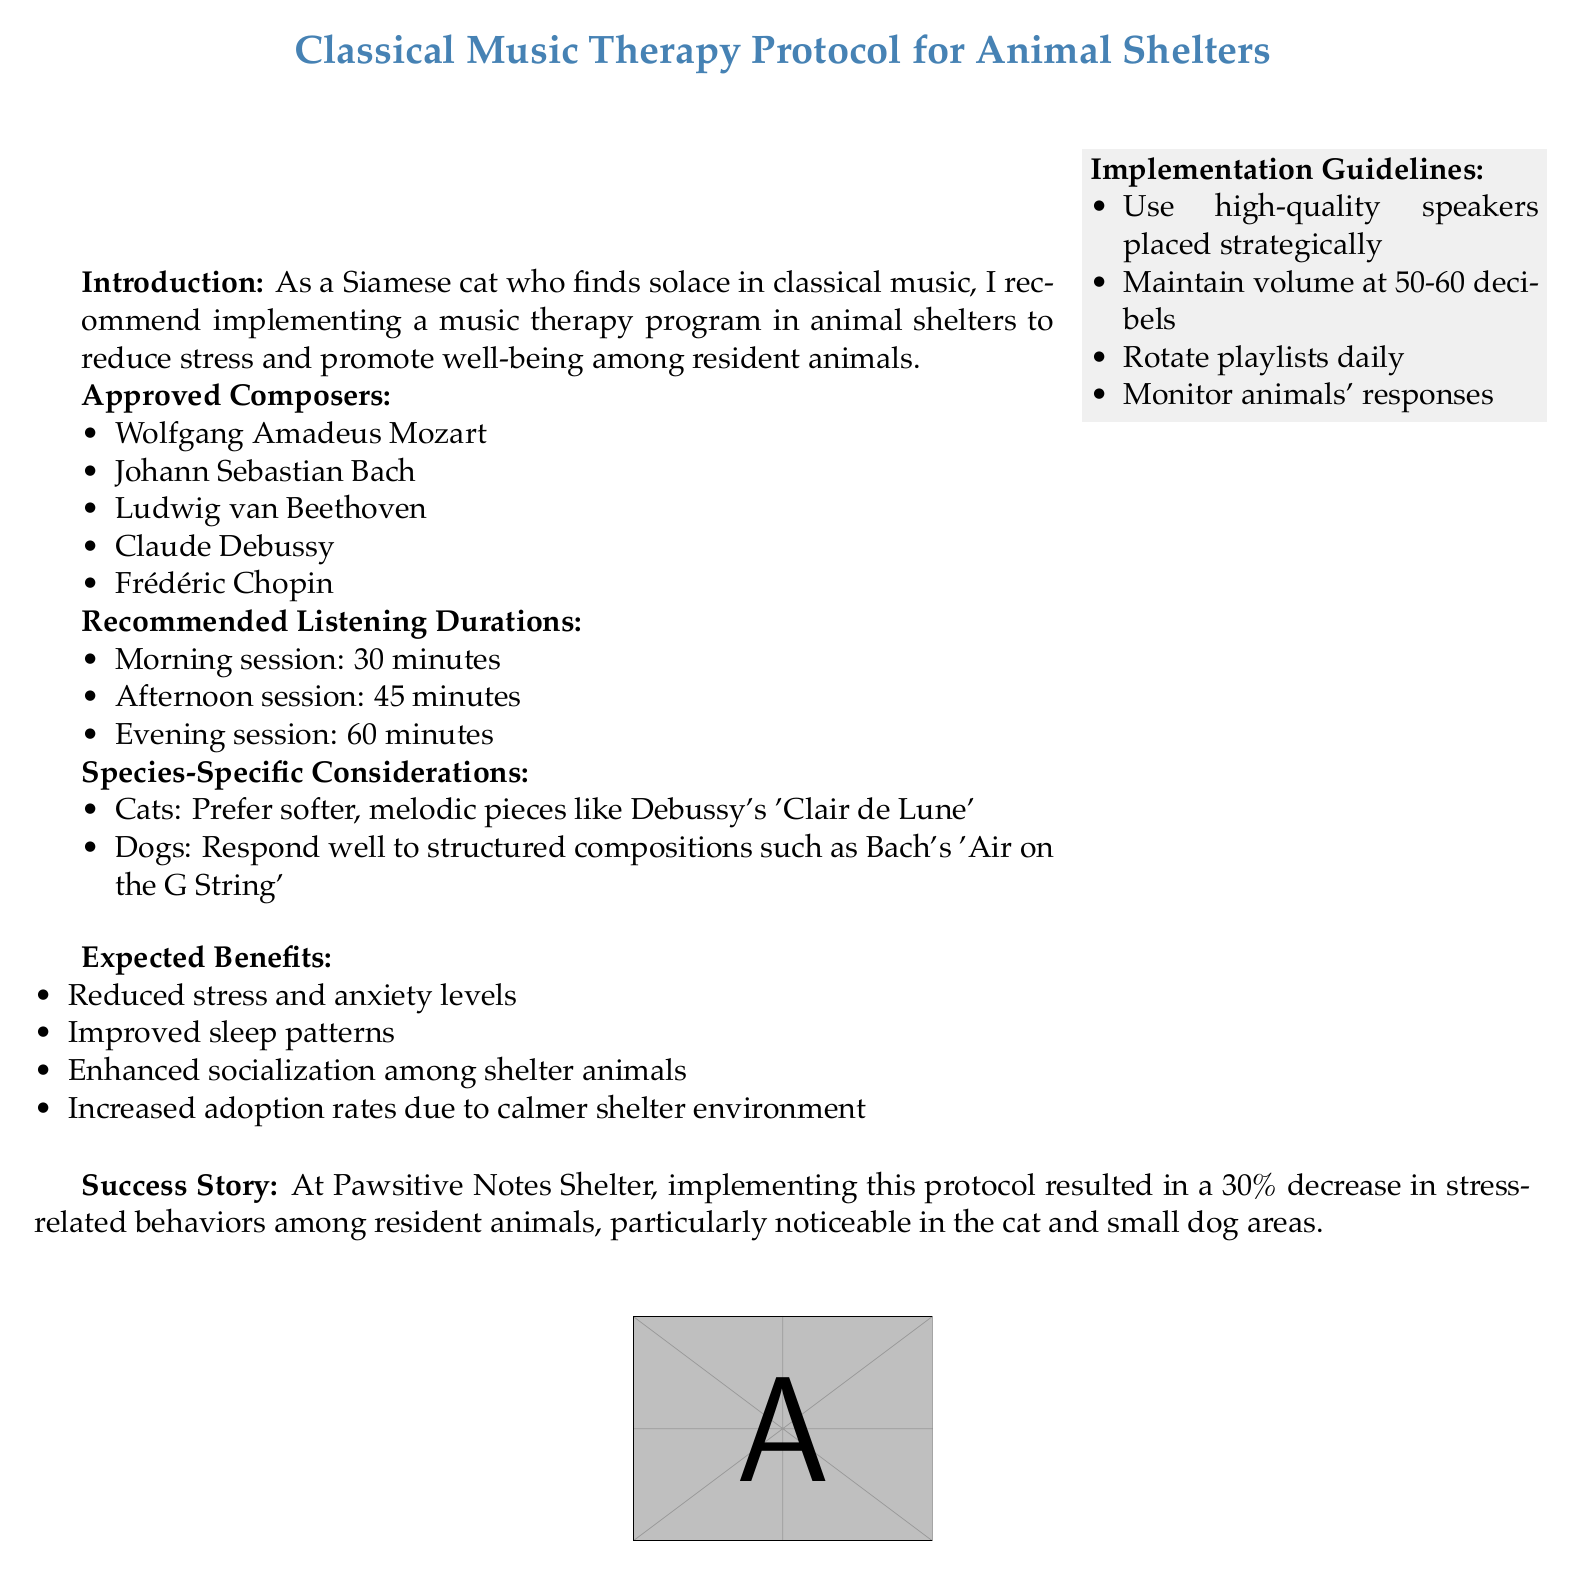What are the approved composers? The approved composers list includes the names mentioned in the document.
Answer: Mozart, Bach, Beethoven, Debussy, Chopin What is the recommended morning listening duration? The document specifies the duration for each listening session.
Answer: 30 minutes Which composer is recommended for dogs? The document states the specific pieces that are preferable for different species.
Answer: Bach What is one expected benefit of the music therapy? The document outlines several benefits expected from the implementation of the therapy.
Answer: Reduced stress and anxiety levels What is the volume level that should be maintained? The document specifies guidelines for implementing the music therapy program.
Answer: 50-60 decibels How much was the decrease in stress-related behaviors at Pawsitive Notes Shelter? The success story provides a quantitative outcome from the implementation of the protocol.
Answer: 30 percent What type of pieces do cats prefer according to the document? The document provides specific recommendations for cats in terms of musical style.
Answer: Softer, melodic pieces 